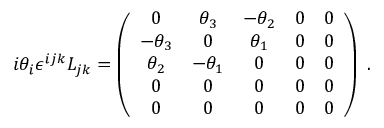Convert formula to latex. <formula><loc_0><loc_0><loc_500><loc_500>i \theta _ { i } \epsilon ^ { i j k } L _ { j k } = \left ( { \begin{array} { c c c c c } { 0 } & { \theta _ { 3 } } & { - \theta _ { 2 } } & { 0 } & { 0 } \\ { - \theta _ { 3 } } & { 0 } & { \theta _ { 1 } } & { 0 } & { 0 } \\ { \theta _ { 2 } } & { - \theta _ { 1 } } & { 0 } & { 0 } & { 0 } \\ { 0 } & { 0 } & { 0 } & { 0 } & { 0 } \\ { 0 } & { 0 } & { 0 } & { 0 } & { 0 } \end{array} } \right ) .</formula> 